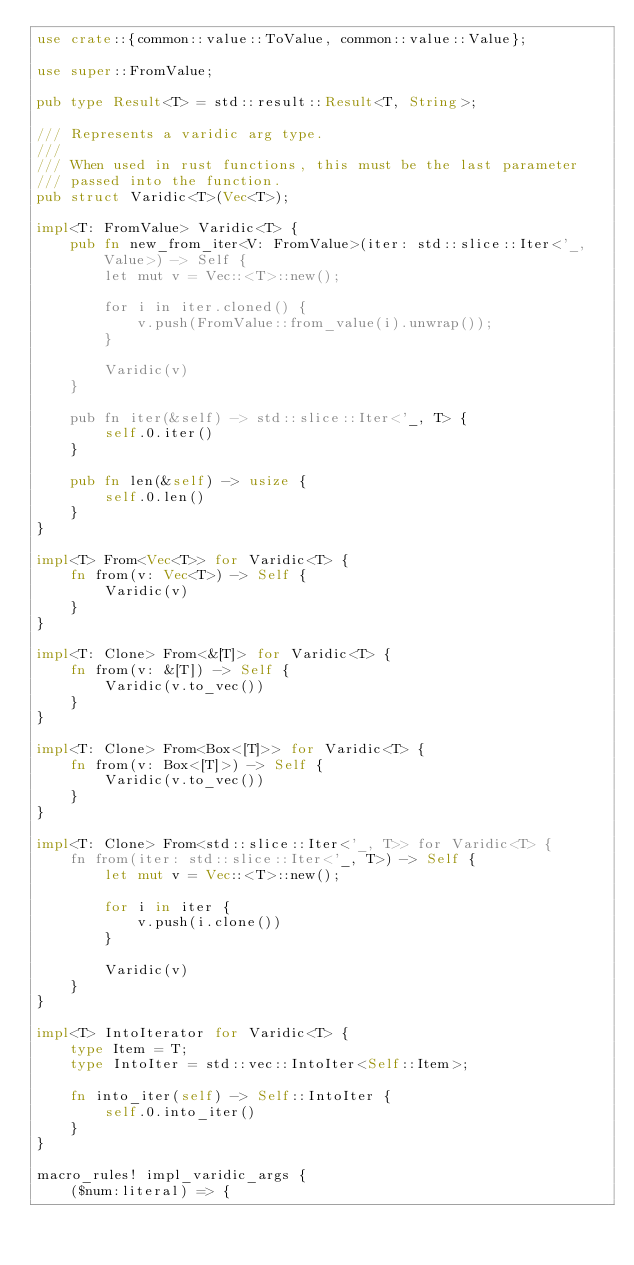Convert code to text. <code><loc_0><loc_0><loc_500><loc_500><_Rust_>use crate::{common::value::ToValue, common::value::Value};

use super::FromValue;

pub type Result<T> = std::result::Result<T, String>;

/// Represents a varidic arg type.
///
/// When used in rust functions, this must be the last parameter
/// passed into the function.
pub struct Varidic<T>(Vec<T>);

impl<T: FromValue> Varidic<T> {
    pub fn new_from_iter<V: FromValue>(iter: std::slice::Iter<'_, Value>) -> Self {
        let mut v = Vec::<T>::new();

        for i in iter.cloned() {
            v.push(FromValue::from_value(i).unwrap());
        }

        Varidic(v)
    }

    pub fn iter(&self) -> std::slice::Iter<'_, T> {
        self.0.iter()
    }

    pub fn len(&self) -> usize {
        self.0.len()
    }  
}

impl<T> From<Vec<T>> for Varidic<T> {
    fn from(v: Vec<T>) -> Self {
        Varidic(v)
    }
}

impl<T: Clone> From<&[T]> for Varidic<T> {
    fn from(v: &[T]) -> Self {
        Varidic(v.to_vec())
    }
}

impl<T: Clone> From<Box<[T]>> for Varidic<T> {
    fn from(v: Box<[T]>) -> Self {
        Varidic(v.to_vec())
    }
}

impl<T: Clone> From<std::slice::Iter<'_, T>> for Varidic<T> {
    fn from(iter: std::slice::Iter<'_, T>) -> Self {
        let mut v = Vec::<T>::new();

        for i in iter {
            v.push(i.clone())
        }

        Varidic(v)
    }
}

impl<T> IntoIterator for Varidic<T> {
    type Item = T;
    type IntoIter = std::vec::IntoIter<Self::Item>;

    fn into_iter(self) -> Self::IntoIter {
        self.0.into_iter()
    }
}

macro_rules! impl_varidic_args {
    ($num:literal) => {</code> 